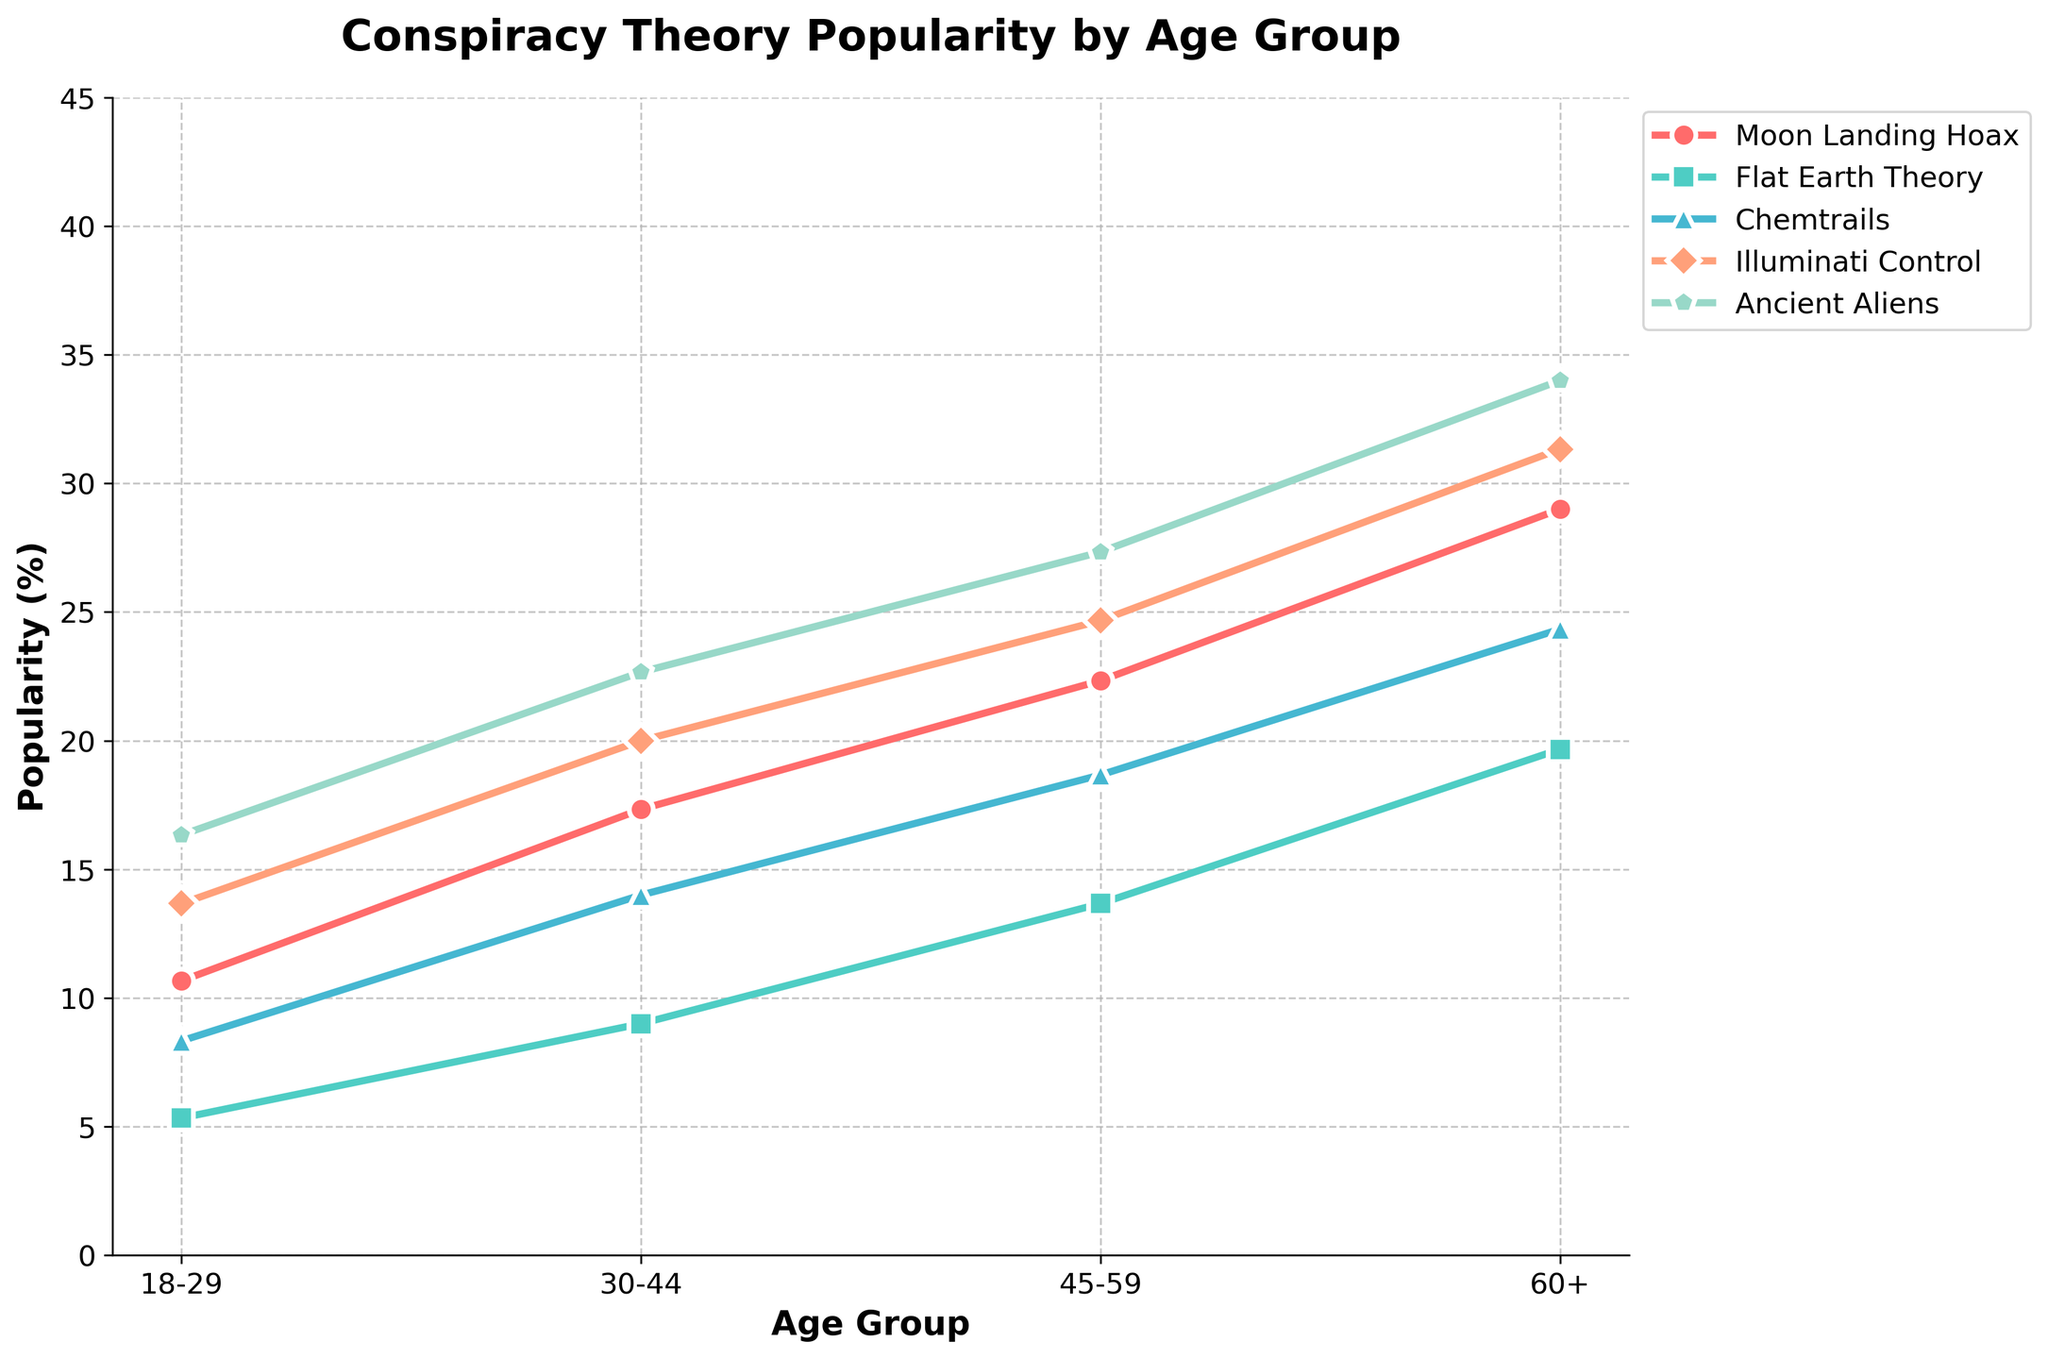What age group has the highest popularity for the Moon Landing Hoax theory? The highest point for the Moon Landing Hoax trend line corresponds to the age group 60+, indicating that this group has the highest popularity for this theory among the residents.
Answer: 60+ Which conspiracy theory is the least popular among 18-29-year-olds with a college education? We can observe each theory's point on the graph for the 18-29 age group with college education and identify the lowest point. The Flat Earth Theory has the lowest value, indicating its least popularity among this demographic.
Answer: Flat Earth Theory Is the Illuminati Control theory more popular among high school graduates aged 45-59 or college graduates aged 60+? We compare the heights of the points on the Illuminati Control trend line for the specified age and education groups. For high school graduates aged 45-59, the chart shows a higher point than for college graduates aged 60+.
Answer: High school graduates aged 45-59 Which theory shows the most significant increase in popularity from the 18-29 to the 60+ age group for high school graduates? Examining the trend lines for all theories among high school graduates, we observe the data points from 18-29 to 60+. The Moon Landing Hoax shows the most significant increase, rising from 15% to 35%.
Answer: Moon Landing Hoax What is the average popularity of the Chemtrails theory across all age groups for people with a graduate degree? To find the average, look at the data points for Chemtrails across all age groups for graduate degree holders (5, 10, 13, 18). Sum these values and divide by the number of points: (5 + 10 + 13 + 18) / 4 = 11.5.
Answer: 11.5 How does the popularity of Ancient Aliens among 30-44 year-olds with a high school education compare to that of 45-59 year-olds with the same education? We compare the point values on the Ancient Aliens trend line for both groups: 28 for 30-44 year-olds and 33 for 45-59 year-olds. The latter has a higher value.
Answer: 45-59 year-olds Which age group has the smallest range of popularity percentages across all the conspiracy theories for graduate degree holders? Calculate the difference between the highest and lowest values for each age group's data points for graduate degree holders. The 18-29 group shows the smallest range: max (11) - min (3) = 8.
Answer: 18-29 